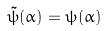Convert formula to latex. <formula><loc_0><loc_0><loc_500><loc_500>\tilde { \psi } ( \alpha ) = \psi ( \alpha )</formula> 